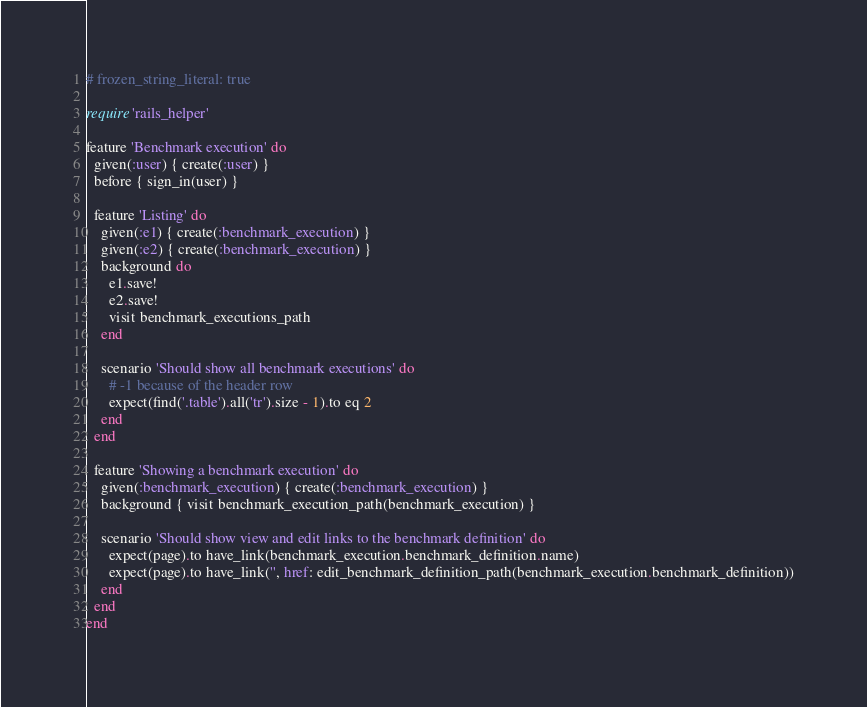<code> <loc_0><loc_0><loc_500><loc_500><_Ruby_># frozen_string_literal: true

require 'rails_helper'

feature 'Benchmark execution' do
  given(:user) { create(:user) }
  before { sign_in(user) }

  feature 'Listing' do
    given(:e1) { create(:benchmark_execution) }
    given(:e2) { create(:benchmark_execution) }
    background do
      e1.save!
      e2.save!
      visit benchmark_executions_path
    end

    scenario 'Should show all benchmark executions' do
      # -1 because of the header row
      expect(find('.table').all('tr').size - 1).to eq 2
    end
  end

  feature 'Showing a benchmark execution' do
    given(:benchmark_execution) { create(:benchmark_execution) }
    background { visit benchmark_execution_path(benchmark_execution) }

    scenario 'Should show view and edit links to the benchmark definition' do
      expect(page).to have_link(benchmark_execution.benchmark_definition.name)
      expect(page).to have_link('', href: edit_benchmark_definition_path(benchmark_execution.benchmark_definition))
    end
  end
end
</code> 